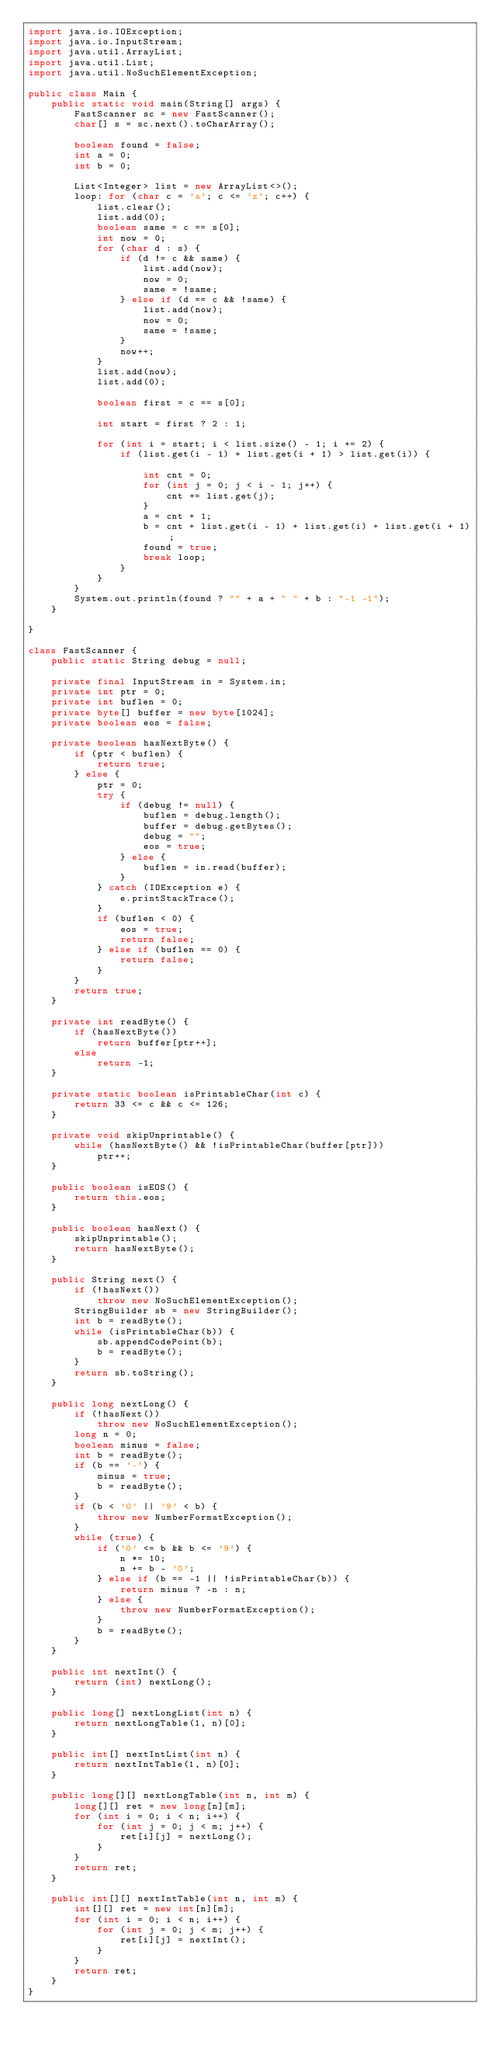<code> <loc_0><loc_0><loc_500><loc_500><_Java_>import java.io.IOException;
import java.io.InputStream;
import java.util.ArrayList;
import java.util.List;
import java.util.NoSuchElementException;

public class Main {
	public static void main(String[] args) {
		FastScanner sc = new FastScanner();
		char[] s = sc.next().toCharArray();

		boolean found = false;
		int a = 0;
		int b = 0;

		List<Integer> list = new ArrayList<>();
		loop: for (char c = 'a'; c <= 'z'; c++) {
			list.clear();
			list.add(0);
			boolean same = c == s[0];
			int now = 0;
			for (char d : s) {
				if (d != c && same) {
					list.add(now);
					now = 0;
					same = !same;
				} else if (d == c && !same) {
					list.add(now);
					now = 0;
					same = !same;
				}
				now++;
			}
			list.add(now);
			list.add(0);

			boolean first = c == s[0];

			int start = first ? 2 : 1;

			for (int i = start; i < list.size() - 1; i += 2) {
				if (list.get(i - 1) + list.get(i + 1) > list.get(i)) {

					int cnt = 0;
					for (int j = 0; j < i - 1; j++) {
						cnt += list.get(j);
					}
					a = cnt + 1;
					b = cnt + list.get(i - 1) + list.get(i) + list.get(i + 1);
					found = true;
					break loop;
				}
			}
		}
		System.out.println(found ? "" + a + " " + b : "-1 -1");
	}

}

class FastScanner {
	public static String debug = null;

	private final InputStream in = System.in;
	private int ptr = 0;
	private int buflen = 0;
	private byte[] buffer = new byte[1024];
	private boolean eos = false;

	private boolean hasNextByte() {
		if (ptr < buflen) {
			return true;
		} else {
			ptr = 0;
			try {
				if (debug != null) {
					buflen = debug.length();
					buffer = debug.getBytes();
					debug = "";
					eos = true;
				} else {
					buflen = in.read(buffer);
				}
			} catch (IOException e) {
				e.printStackTrace();
			}
			if (buflen < 0) {
				eos = true;
				return false;
			} else if (buflen == 0) {
				return false;
			}
		}
		return true;
	}

	private int readByte() {
		if (hasNextByte())
			return buffer[ptr++];
		else
			return -1;
	}

	private static boolean isPrintableChar(int c) {
		return 33 <= c && c <= 126;
	}

	private void skipUnprintable() {
		while (hasNextByte() && !isPrintableChar(buffer[ptr]))
			ptr++;
	}

	public boolean isEOS() {
		return this.eos;
	}

	public boolean hasNext() {
		skipUnprintable();
		return hasNextByte();
	}

	public String next() {
		if (!hasNext())
			throw new NoSuchElementException();
		StringBuilder sb = new StringBuilder();
		int b = readByte();
		while (isPrintableChar(b)) {
			sb.appendCodePoint(b);
			b = readByte();
		}
		return sb.toString();
	}

	public long nextLong() {
		if (!hasNext())
			throw new NoSuchElementException();
		long n = 0;
		boolean minus = false;
		int b = readByte();
		if (b == '-') {
			minus = true;
			b = readByte();
		}
		if (b < '0' || '9' < b) {
			throw new NumberFormatException();
		}
		while (true) {
			if ('0' <= b && b <= '9') {
				n *= 10;
				n += b - '0';
			} else if (b == -1 || !isPrintableChar(b)) {
				return minus ? -n : n;
			} else {
				throw new NumberFormatException();
			}
			b = readByte();
		}
	}

	public int nextInt() {
		return (int) nextLong();
	}

	public long[] nextLongList(int n) {
		return nextLongTable(1, n)[0];
	}

	public int[] nextIntList(int n) {
		return nextIntTable(1, n)[0];
	}

	public long[][] nextLongTable(int n, int m) {
		long[][] ret = new long[n][m];
		for (int i = 0; i < n; i++) {
			for (int j = 0; j < m; j++) {
				ret[i][j] = nextLong();
			}
		}
		return ret;
	}

	public int[][] nextIntTable(int n, int m) {
		int[][] ret = new int[n][m];
		for (int i = 0; i < n; i++) {
			for (int j = 0; j < m; j++) {
				ret[i][j] = nextInt();
			}
		}
		return ret;
	}
}</code> 